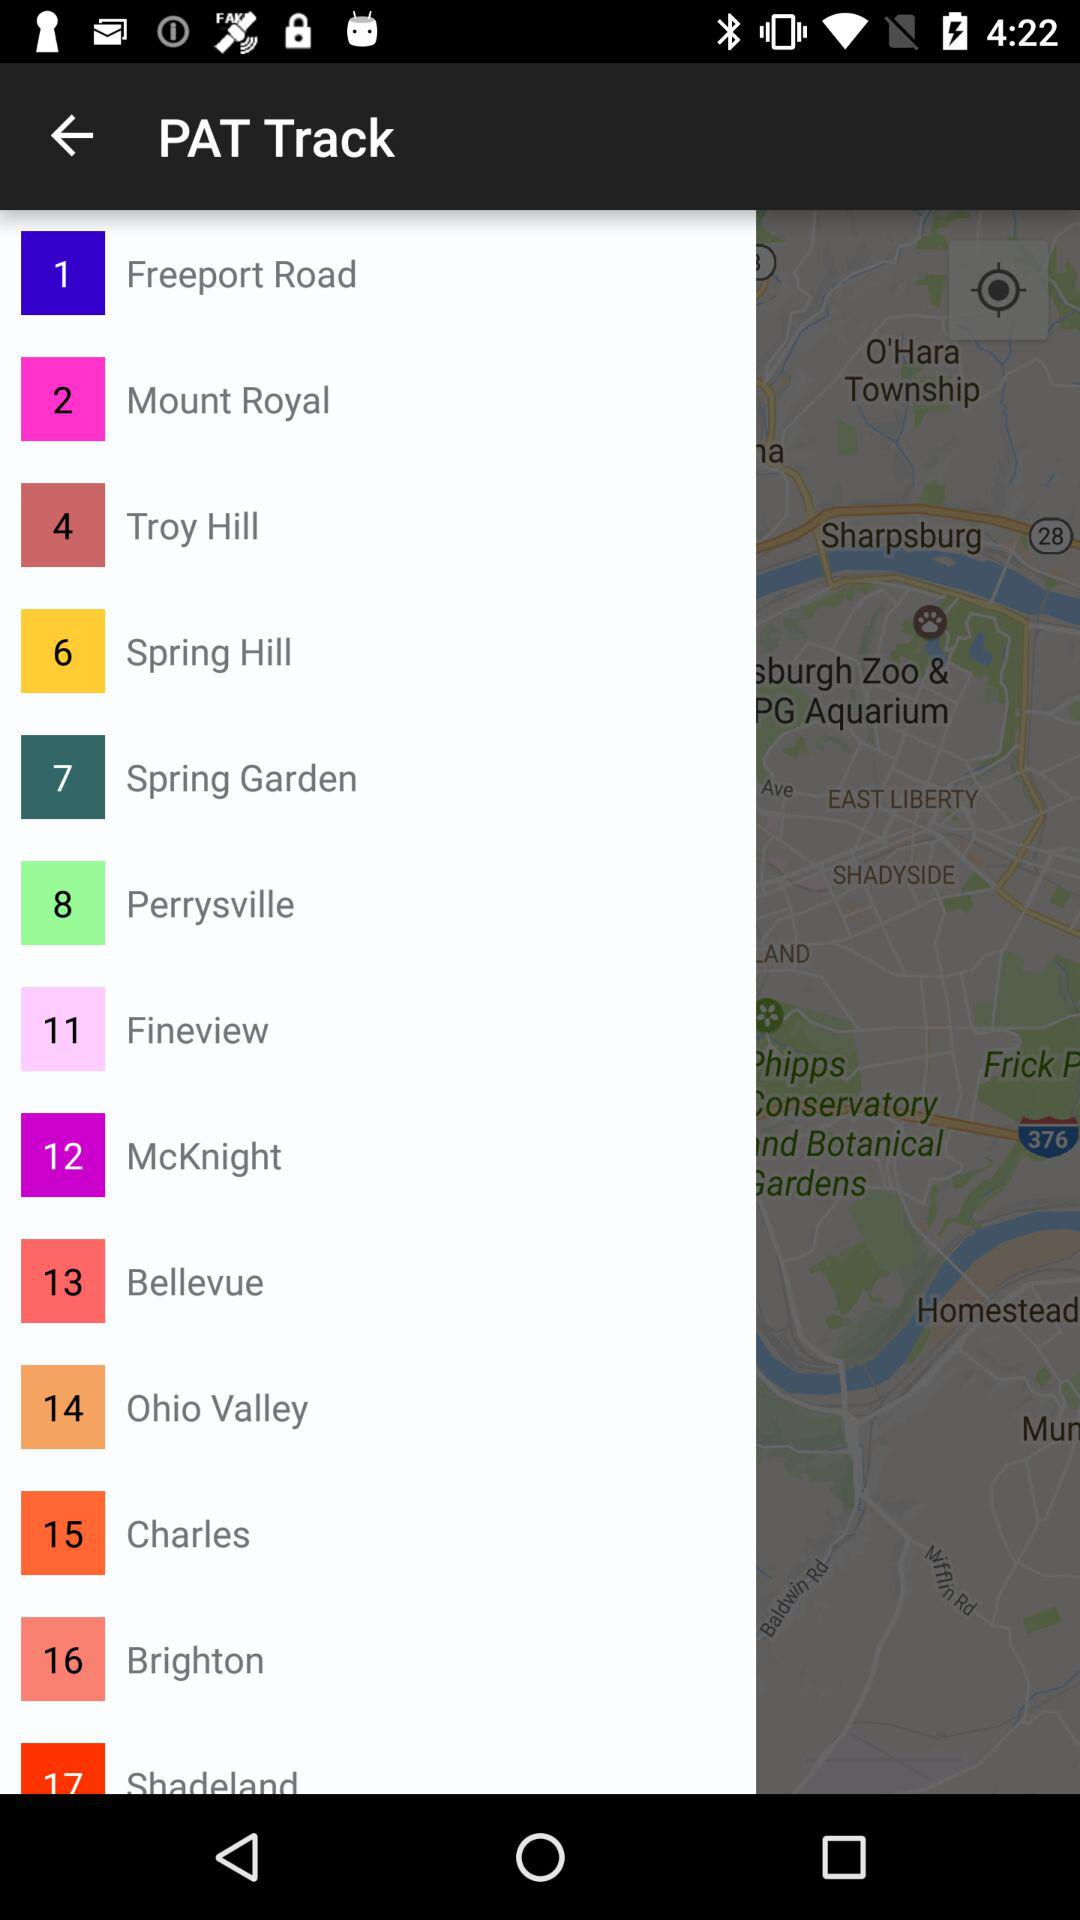What is the number for the spring garden? The number is 7. 